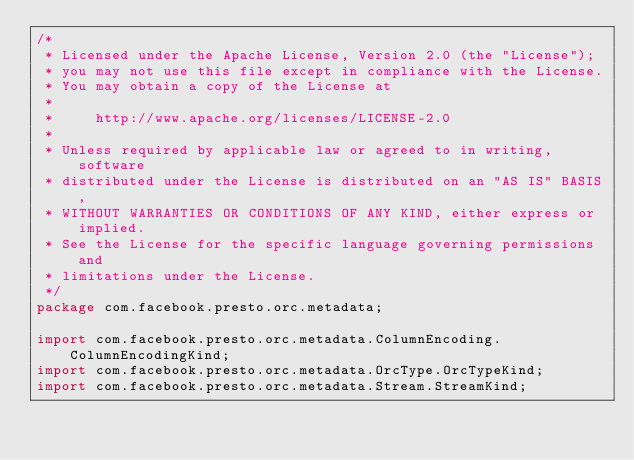<code> <loc_0><loc_0><loc_500><loc_500><_Java_>/*
 * Licensed under the Apache License, Version 2.0 (the "License");
 * you may not use this file except in compliance with the License.
 * You may obtain a copy of the License at
 *
 *     http://www.apache.org/licenses/LICENSE-2.0
 *
 * Unless required by applicable law or agreed to in writing, software
 * distributed under the License is distributed on an "AS IS" BASIS,
 * WITHOUT WARRANTIES OR CONDITIONS OF ANY KIND, either express or implied.
 * See the License for the specific language governing permissions and
 * limitations under the License.
 */
package com.facebook.presto.orc.metadata;

import com.facebook.presto.orc.metadata.ColumnEncoding.ColumnEncodingKind;
import com.facebook.presto.orc.metadata.OrcType.OrcTypeKind;
import com.facebook.presto.orc.metadata.Stream.StreamKind;</code> 